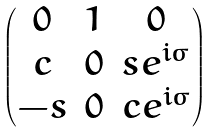Convert formula to latex. <formula><loc_0><loc_0><loc_500><loc_500>\begin{pmatrix} 0 & 1 & 0 \\ c & 0 & s e ^ { i \sigma } \\ - s & 0 & c e ^ { i \sigma } \end{pmatrix}</formula> 